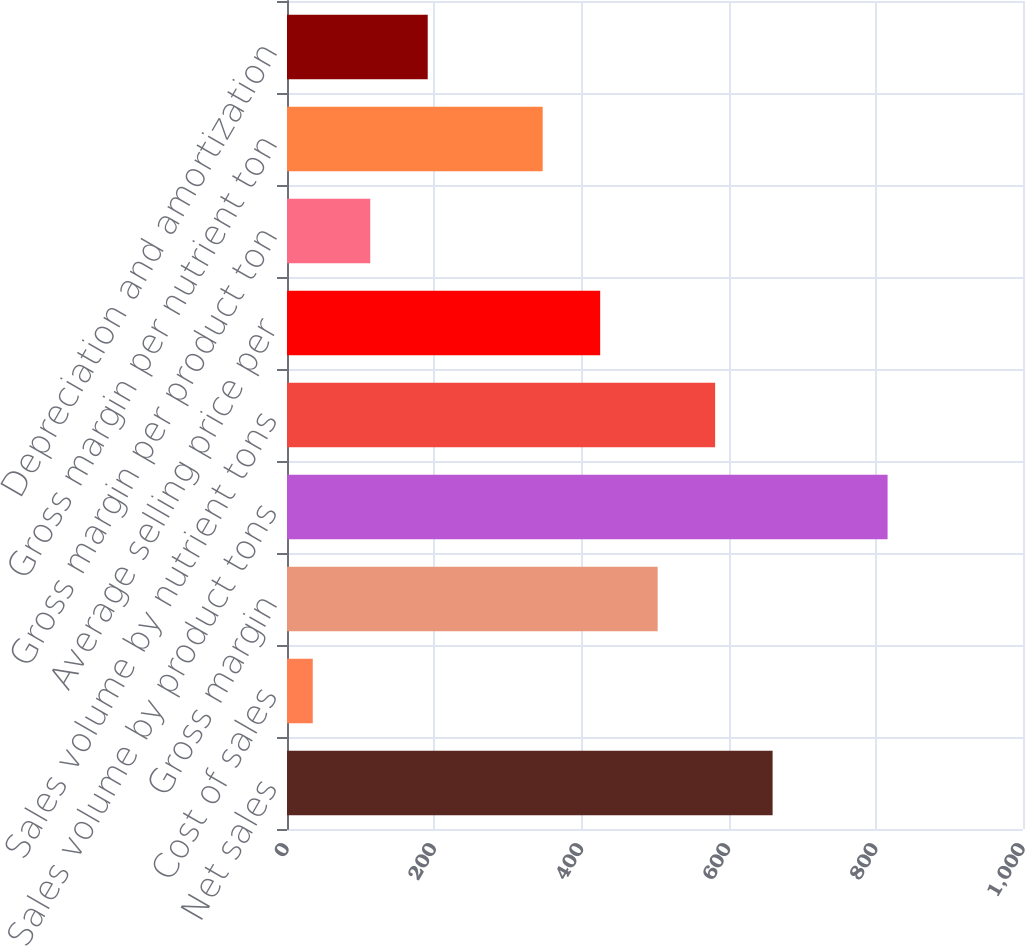Convert chart to OTSL. <chart><loc_0><loc_0><loc_500><loc_500><bar_chart><fcel>Net sales<fcel>Cost of sales<fcel>Gross margin<fcel>Sales volume by product tons<fcel>Sales volume by nutrient tons<fcel>Average selling price per<fcel>Gross margin per product ton<fcel>Gross margin per nutrient ton<fcel>Depreciation and amortization<nl><fcel>659.8<fcel>35<fcel>503.6<fcel>816<fcel>581.7<fcel>425.5<fcel>113.1<fcel>347.4<fcel>191.2<nl></chart> 